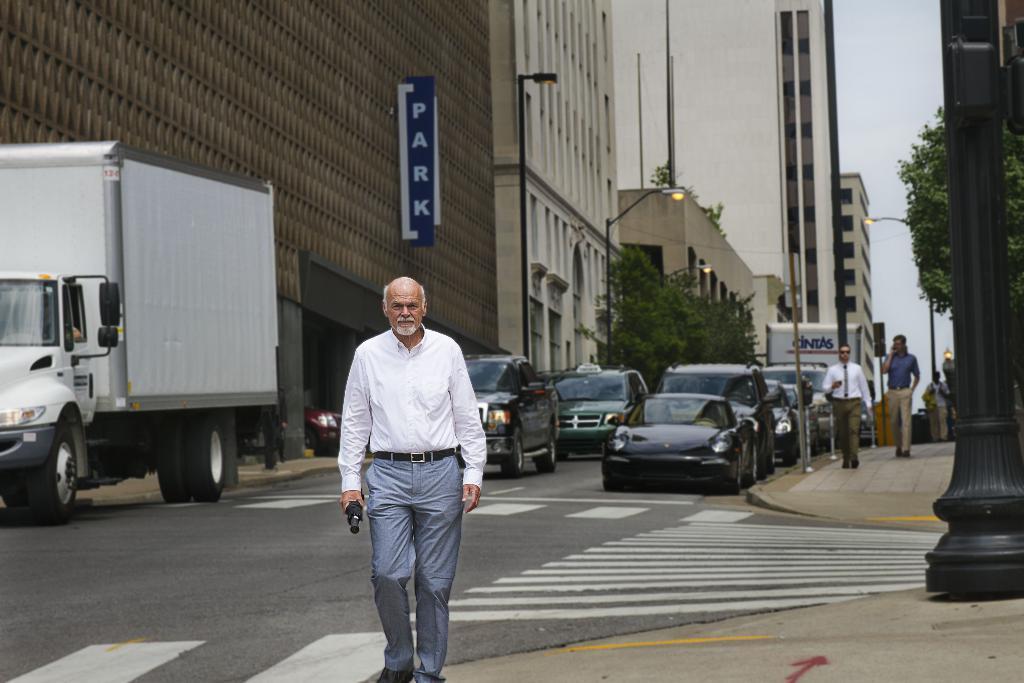Can you describe this image briefly? In this image I can see a person wearing white and grey colored dress is standing and holding a black colored object in his hand. I can see the road, few vehicles on the road, few persons standing on the side walk, a black colored pole, few trees, few buildings and in the background I can see the sky. 